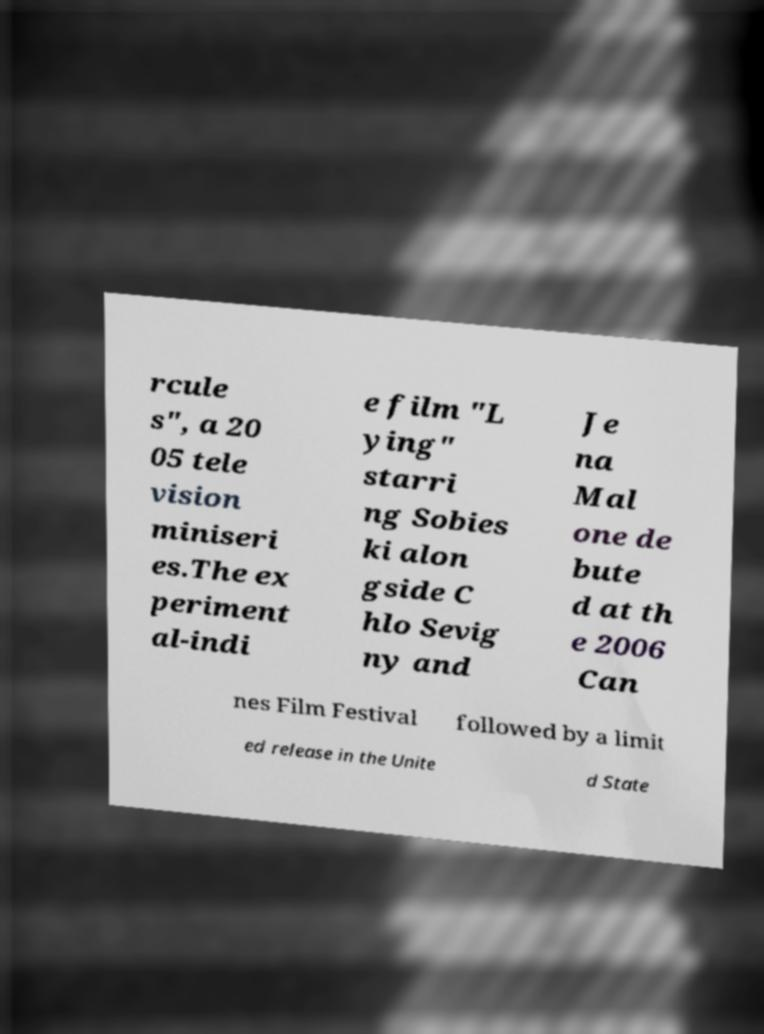Can you read and provide the text displayed in the image?This photo seems to have some interesting text. Can you extract and type it out for me? rcule s", a 20 05 tele vision miniseri es.The ex periment al-indi e film "L ying" starri ng Sobies ki alon gside C hlo Sevig ny and Je na Mal one de bute d at th e 2006 Can nes Film Festival followed by a limit ed release in the Unite d State 